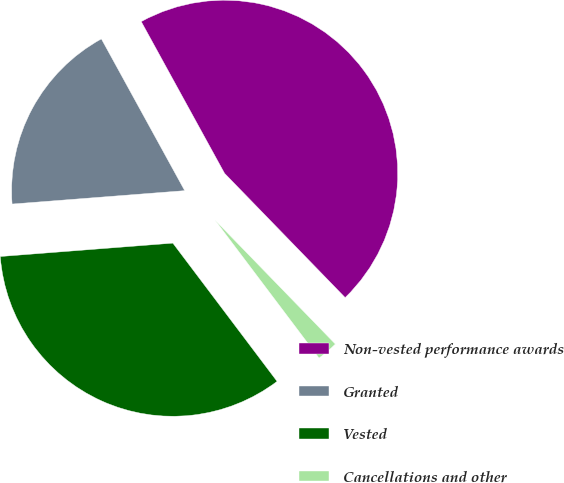Convert chart to OTSL. <chart><loc_0><loc_0><loc_500><loc_500><pie_chart><fcel>Non-vested performance awards<fcel>Granted<fcel>Vested<fcel>Cancellations and other<nl><fcel>45.73%<fcel>18.24%<fcel>34.05%<fcel>1.98%<nl></chart> 